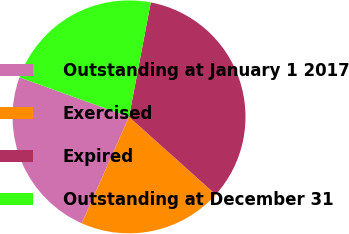Convert chart. <chart><loc_0><loc_0><loc_500><loc_500><pie_chart><fcel>Outstanding at January 1 2017<fcel>Exercised<fcel>Expired<fcel>Outstanding at December 31<nl><fcel>23.85%<fcel>20.02%<fcel>33.63%<fcel>22.49%<nl></chart> 